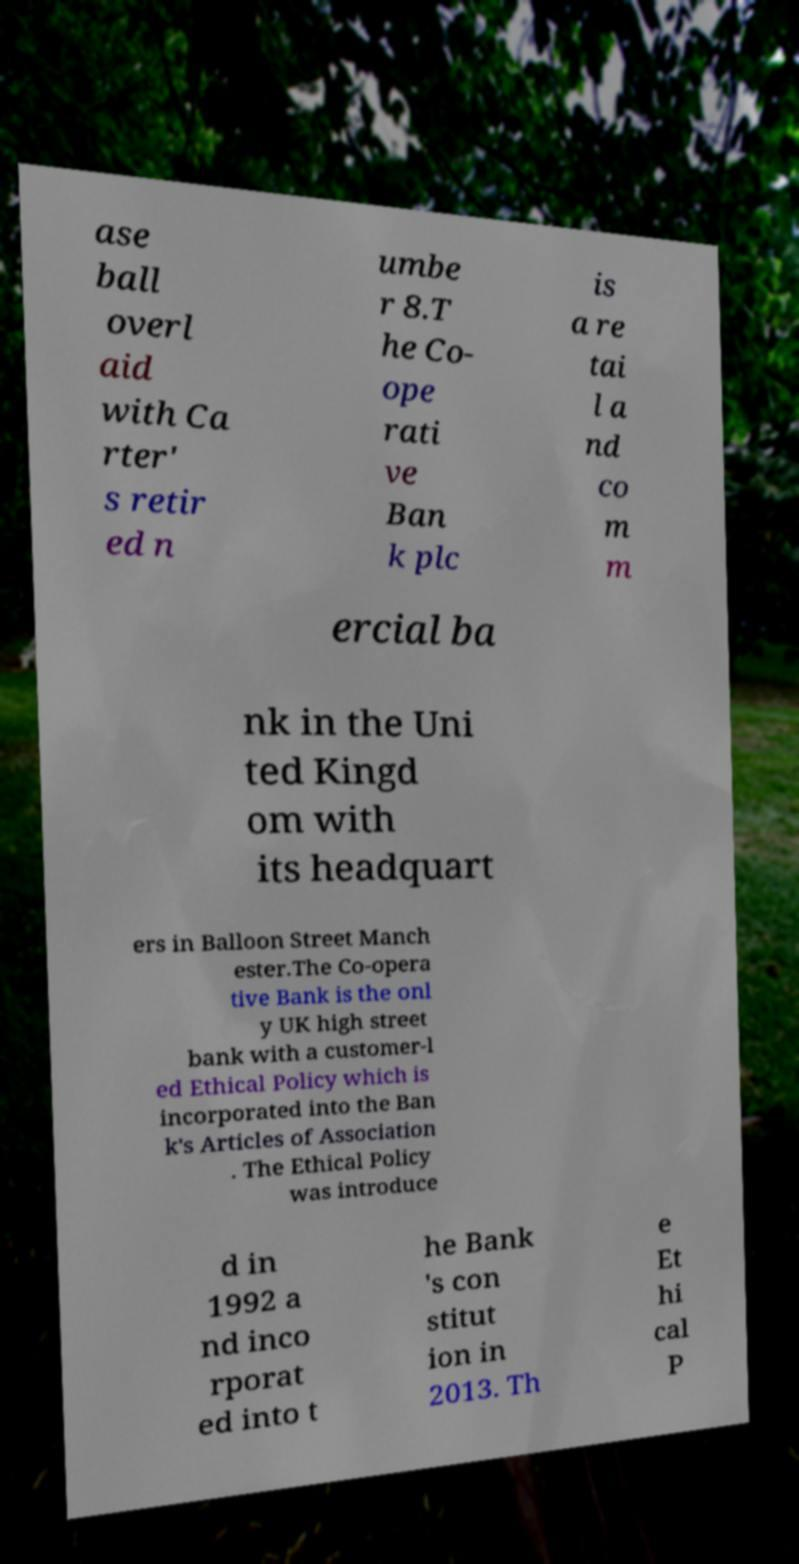For documentation purposes, I need the text within this image transcribed. Could you provide that? ase ball overl aid with Ca rter' s retir ed n umbe r 8.T he Co- ope rati ve Ban k plc is a re tai l a nd co m m ercial ba nk in the Uni ted Kingd om with its headquart ers in Balloon Street Manch ester.The Co-opera tive Bank is the onl y UK high street bank with a customer-l ed Ethical Policy which is incorporated into the Ban k's Articles of Association . The Ethical Policy was introduce d in 1992 a nd inco rporat ed into t he Bank 's con stitut ion in 2013. Th e Et hi cal P 